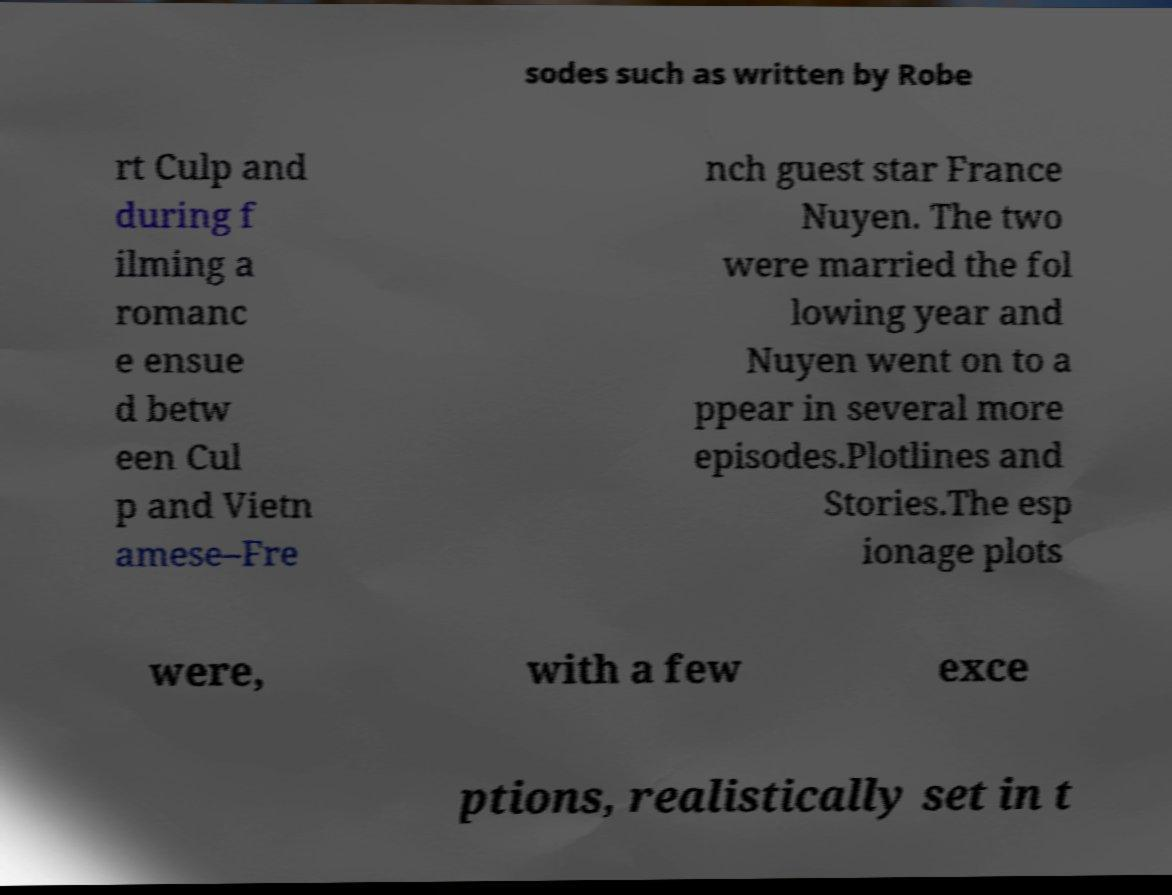Can you accurately transcribe the text from the provided image for me? sodes such as written by Robe rt Culp and during f ilming a romanc e ensue d betw een Cul p and Vietn amese–Fre nch guest star France Nuyen. The two were married the fol lowing year and Nuyen went on to a ppear in several more episodes.Plotlines and Stories.The esp ionage plots were, with a few exce ptions, realistically set in t 